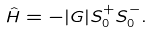<formula> <loc_0><loc_0><loc_500><loc_500>\hat { H } = - | G | S ^ { + } _ { 0 } S ^ { - } _ { 0 } .</formula> 